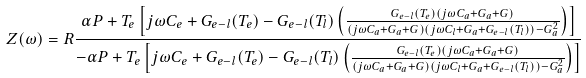Convert formula to latex. <formula><loc_0><loc_0><loc_500><loc_500>Z ( \omega ) = R \frac { \alpha P + T _ { e } \left [ j \omega C _ { e } + G _ { e - l } ( T _ { e } ) - G _ { e - l } ( T _ { l } ) \left ( \frac { G _ { e - l } ( T _ { e } ) ( j \omega C _ { a } + G _ { a } + G ) } { ( j \omega C _ { a } + G _ { a } + G ) ( j \omega C _ { l } + G _ { a } + G _ { e - l } ( T _ { l } ) ) - G _ { a } ^ { 2 } } \right ) \right ] } { - \alpha P + T _ { e } \left [ j \omega C _ { e } + G _ { e - l } ( T _ { e } ) - G _ { e - l } ( T _ { l } ) \left ( \frac { G _ { e - l } ( T _ { e } ) ( j \omega C _ { a } + G _ { a } + G ) } { ( j \omega C _ { a } + G _ { a } + G ) ( j \omega C _ { l } + G _ { a } + G _ { e - l } ( T _ { l } ) ) - G _ { a } ^ { 2 } } \right ) \right ] }</formula> 